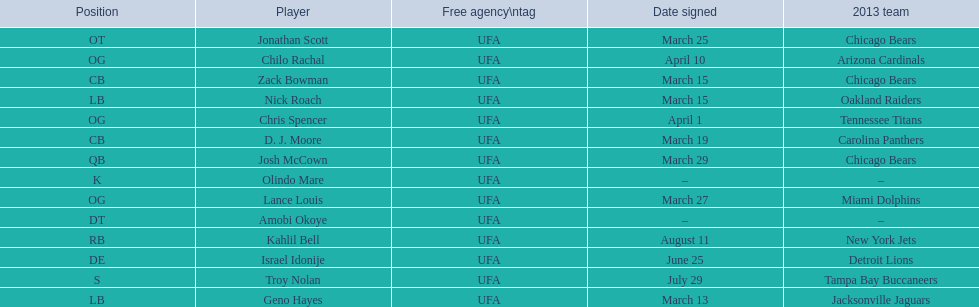How many players play cb or og? 5. Would you be able to parse every entry in this table? {'header': ['Position', 'Player', 'Free agency\\ntag', 'Date signed', '2013 team'], 'rows': [['OT', 'Jonathan Scott', 'UFA', 'March 25', 'Chicago Bears'], ['OG', 'Chilo Rachal', 'UFA', 'April 10', 'Arizona Cardinals'], ['CB', 'Zack Bowman', 'UFA', 'March 15', 'Chicago Bears'], ['LB', 'Nick Roach', 'UFA', 'March 15', 'Oakland Raiders'], ['OG', 'Chris Spencer', 'UFA', 'April 1', 'Tennessee Titans'], ['CB', 'D. J. Moore', 'UFA', 'March 19', 'Carolina Panthers'], ['QB', 'Josh McCown', 'UFA', 'March 29', 'Chicago Bears'], ['K', 'Olindo Mare', 'UFA', '–', '–'], ['OG', 'Lance Louis', 'UFA', 'March 27', 'Miami Dolphins'], ['DT', 'Amobi Okoye', 'UFA', '–', '–'], ['RB', 'Kahlil Bell', 'UFA', 'August 11', 'New York Jets'], ['DE', 'Israel Idonije', 'UFA', 'June 25', 'Detroit Lions'], ['S', 'Troy Nolan', 'UFA', 'July 29', 'Tampa Bay Buccaneers'], ['LB', 'Geno Hayes', 'UFA', 'March 13', 'Jacksonville Jaguars']]} 